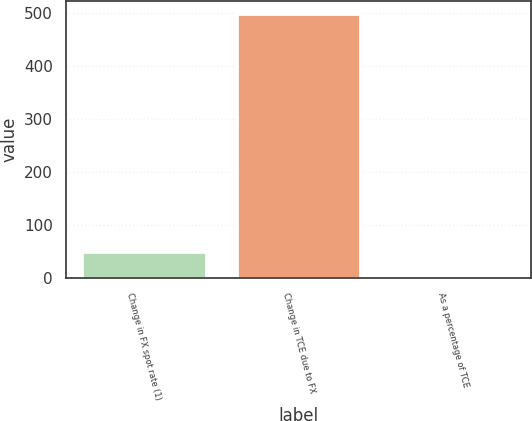<chart> <loc_0><loc_0><loc_500><loc_500><bar_chart><fcel>Change in FX spot rate (1)<fcel>Change in TCE due to FX<fcel>As a percentage of TCE<nl><fcel>50.07<fcel>498<fcel>0.3<nl></chart> 